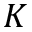Convert formula to latex. <formula><loc_0><loc_0><loc_500><loc_500>K</formula> 